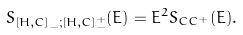<formula> <loc_0><loc_0><loc_500><loc_500>S _ { \left [ H , C \right ] _ { - } ; \left [ H , C \right ] _ { - } ^ { + } } ( E ) = E ^ { 2 } S _ { C C ^ { + } } ( E ) .</formula> 